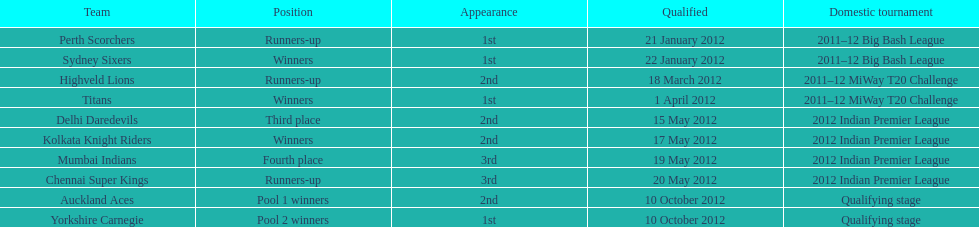Which teams were the last to qualify? Auckland Aces, Yorkshire Carnegie. 